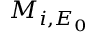<formula> <loc_0><loc_0><loc_500><loc_500>M _ { i , E _ { 0 } }</formula> 